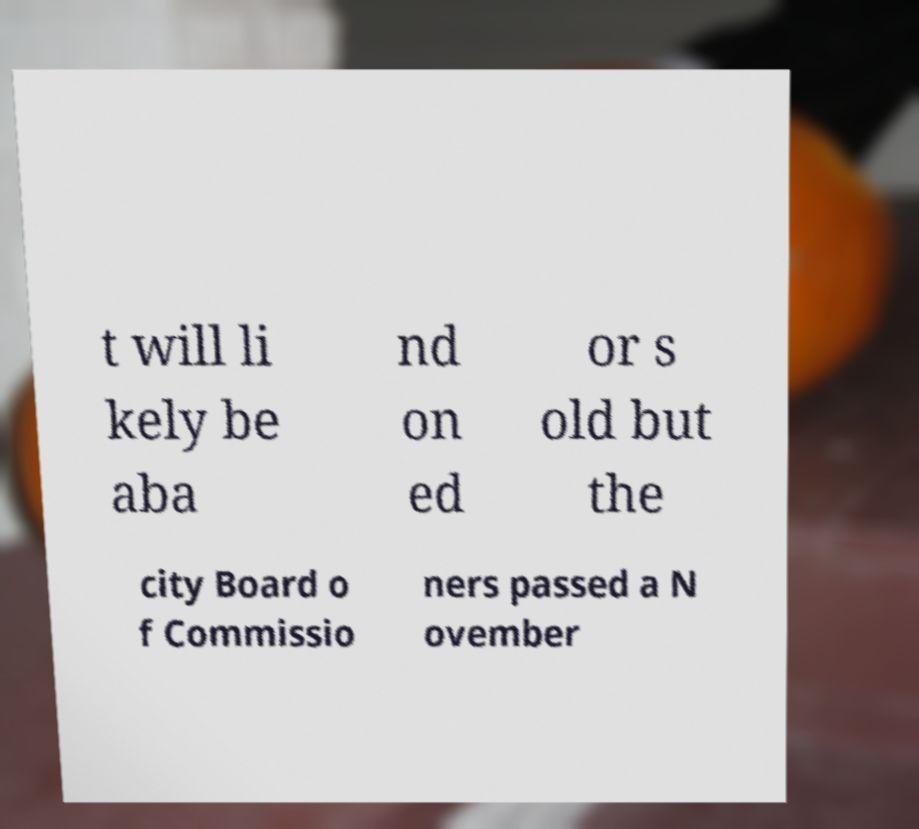Can you read and provide the text displayed in the image?This photo seems to have some interesting text. Can you extract and type it out for me? t will li kely be aba nd on ed or s old but the city Board o f Commissio ners passed a N ovember 